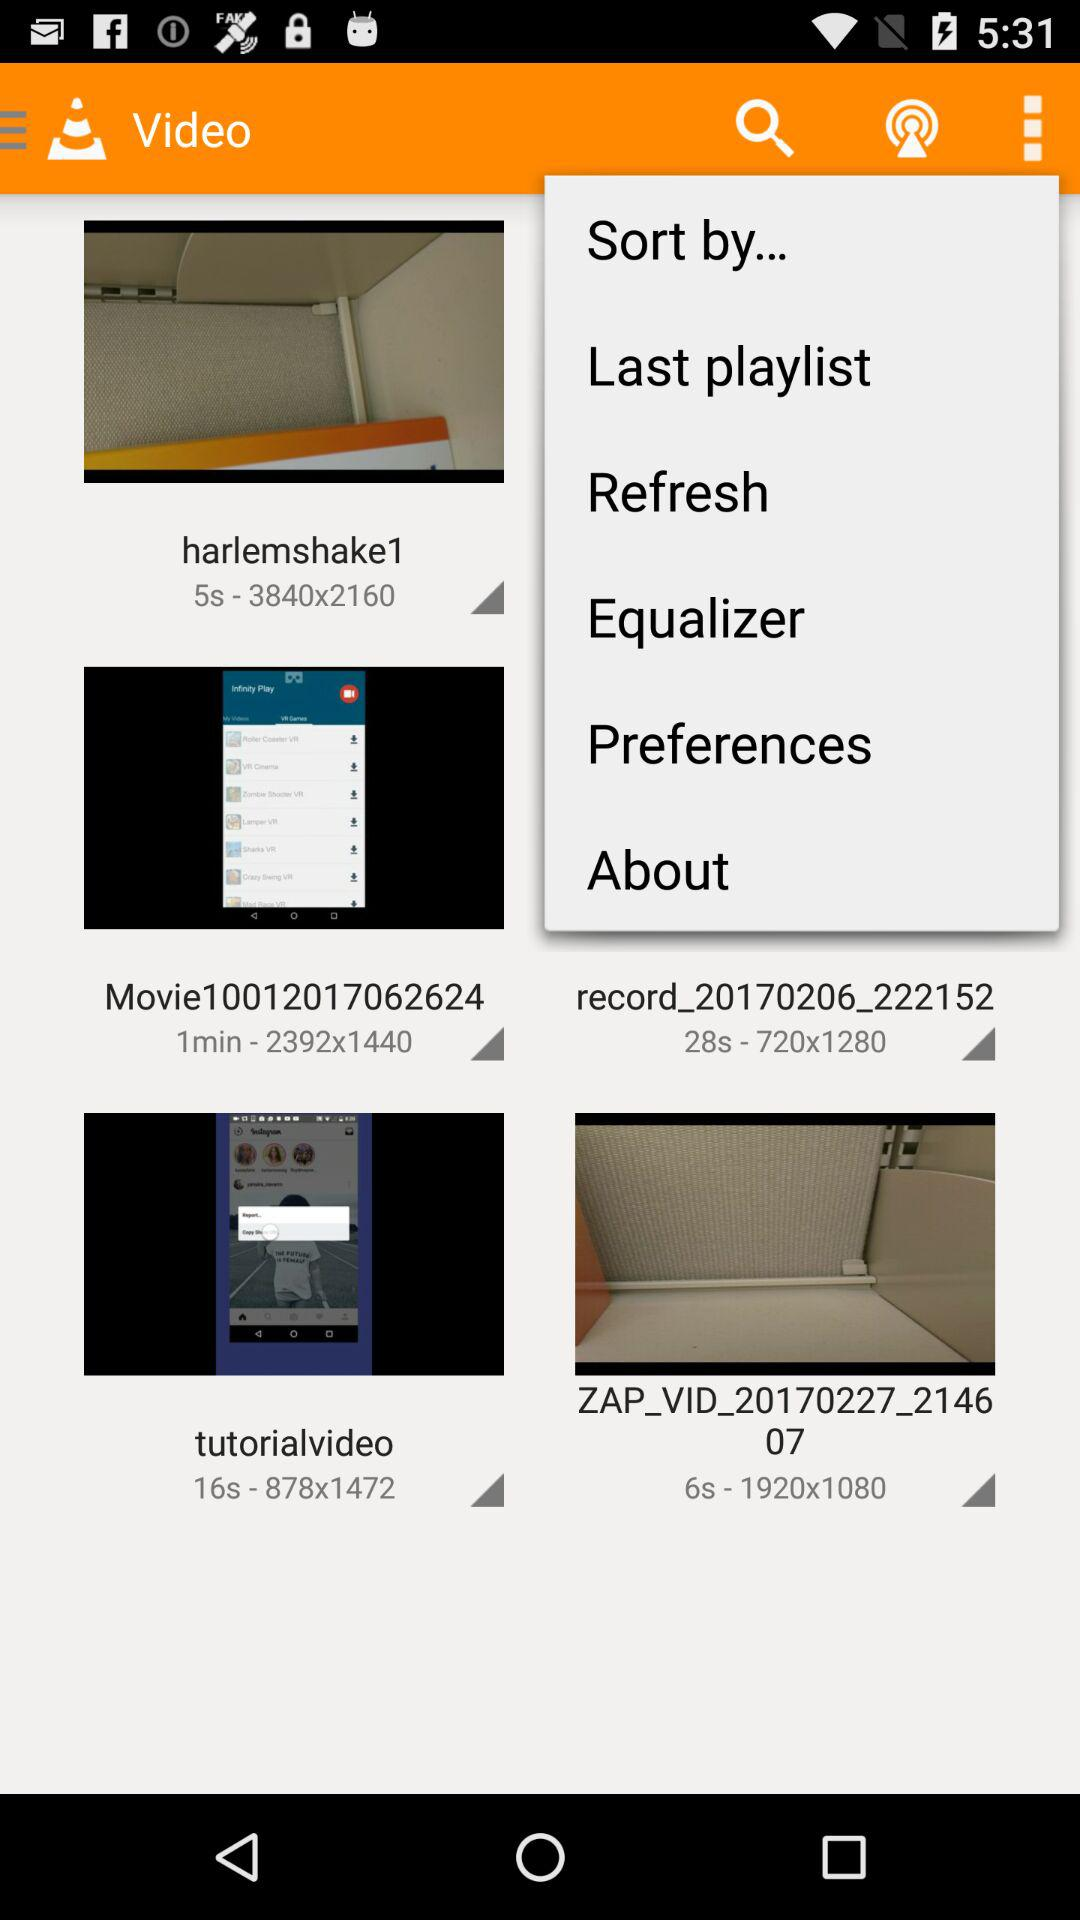What are the dimensions of "harlemshake1"? The dimensions are 3840×2160. 